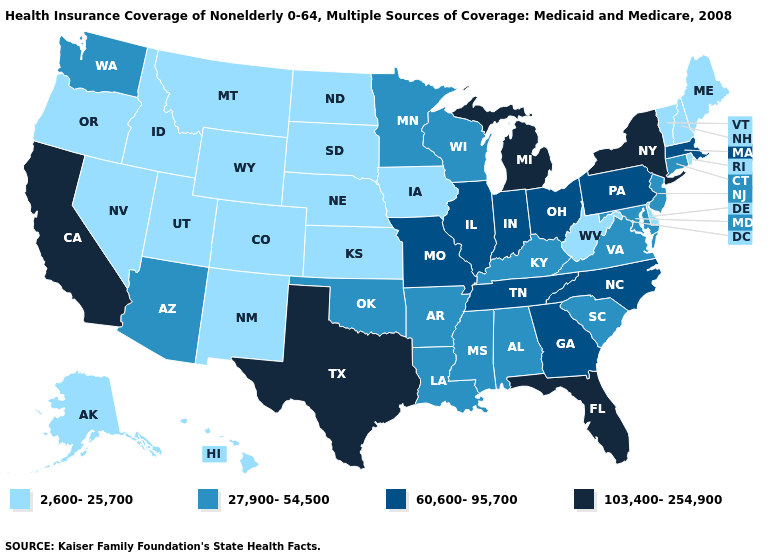Among the states that border Texas , which have the highest value?
Short answer required. Arkansas, Louisiana, Oklahoma. Does Wisconsin have the lowest value in the MidWest?
Keep it brief. No. What is the lowest value in the USA?
Give a very brief answer. 2,600-25,700. Name the states that have a value in the range 60,600-95,700?
Write a very short answer. Georgia, Illinois, Indiana, Massachusetts, Missouri, North Carolina, Ohio, Pennsylvania, Tennessee. Among the states that border Idaho , does Washington have the lowest value?
Short answer required. No. How many symbols are there in the legend?
Quick response, please. 4. What is the value of North Carolina?
Quick response, please. 60,600-95,700. How many symbols are there in the legend?
Concise answer only. 4. Name the states that have a value in the range 27,900-54,500?
Write a very short answer. Alabama, Arizona, Arkansas, Connecticut, Kentucky, Louisiana, Maryland, Minnesota, Mississippi, New Jersey, Oklahoma, South Carolina, Virginia, Washington, Wisconsin. Among the states that border Alabama , which have the highest value?
Keep it brief. Florida. Name the states that have a value in the range 60,600-95,700?
Keep it brief. Georgia, Illinois, Indiana, Massachusetts, Missouri, North Carolina, Ohio, Pennsylvania, Tennessee. What is the value of Idaho?
Answer briefly. 2,600-25,700. Among the states that border Georgia , which have the lowest value?
Quick response, please. Alabama, South Carolina. Among the states that border Indiana , which have the lowest value?
Short answer required. Kentucky. Name the states that have a value in the range 27,900-54,500?
Concise answer only. Alabama, Arizona, Arkansas, Connecticut, Kentucky, Louisiana, Maryland, Minnesota, Mississippi, New Jersey, Oklahoma, South Carolina, Virginia, Washington, Wisconsin. 